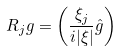<formula> <loc_0><loc_0><loc_500><loc_500>R _ { j } g = \left ( \frac { \xi _ { j } } { i | \xi | } \hat { g } \right ) ^ { }</formula> 